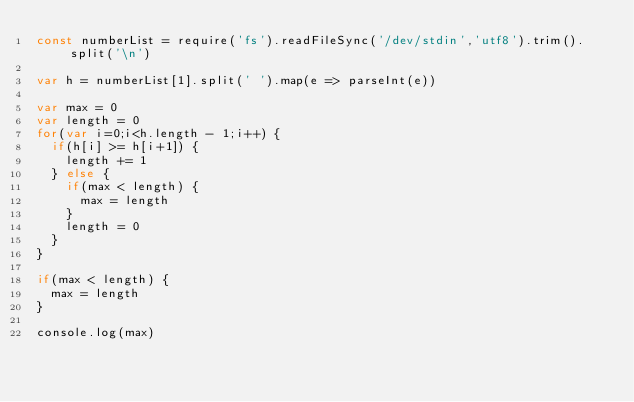Convert code to text. <code><loc_0><loc_0><loc_500><loc_500><_JavaScript_>const numberList = require('fs').readFileSync('/dev/stdin','utf8').trim().split('\n')

var h = numberList[1].split(' ').map(e => parseInt(e))

var max = 0
var length = 0
for(var i=0;i<h.length - 1;i++) {
  if(h[i] >= h[i+1]) {
    length += 1
  } else {
    if(max < length) {
      max = length
    }
    length = 0
  }
}

if(max < length) {
  max = length
}

console.log(max)
</code> 